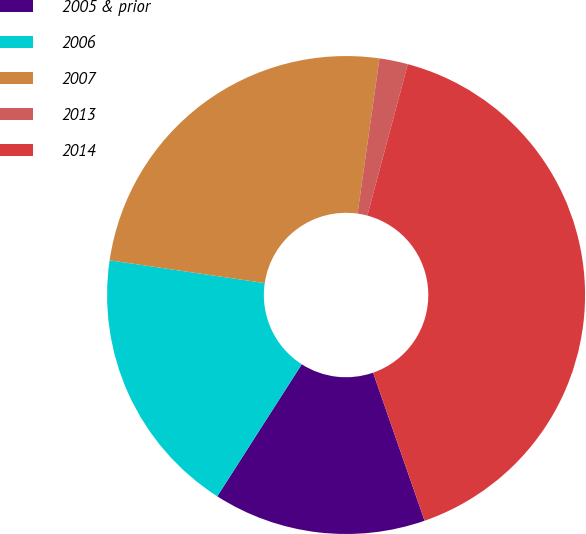Convert chart. <chart><loc_0><loc_0><loc_500><loc_500><pie_chart><fcel>2005 & prior<fcel>2006<fcel>2007<fcel>2013<fcel>2014<nl><fcel>14.39%<fcel>18.26%<fcel>24.91%<fcel>1.93%<fcel>40.51%<nl></chart> 